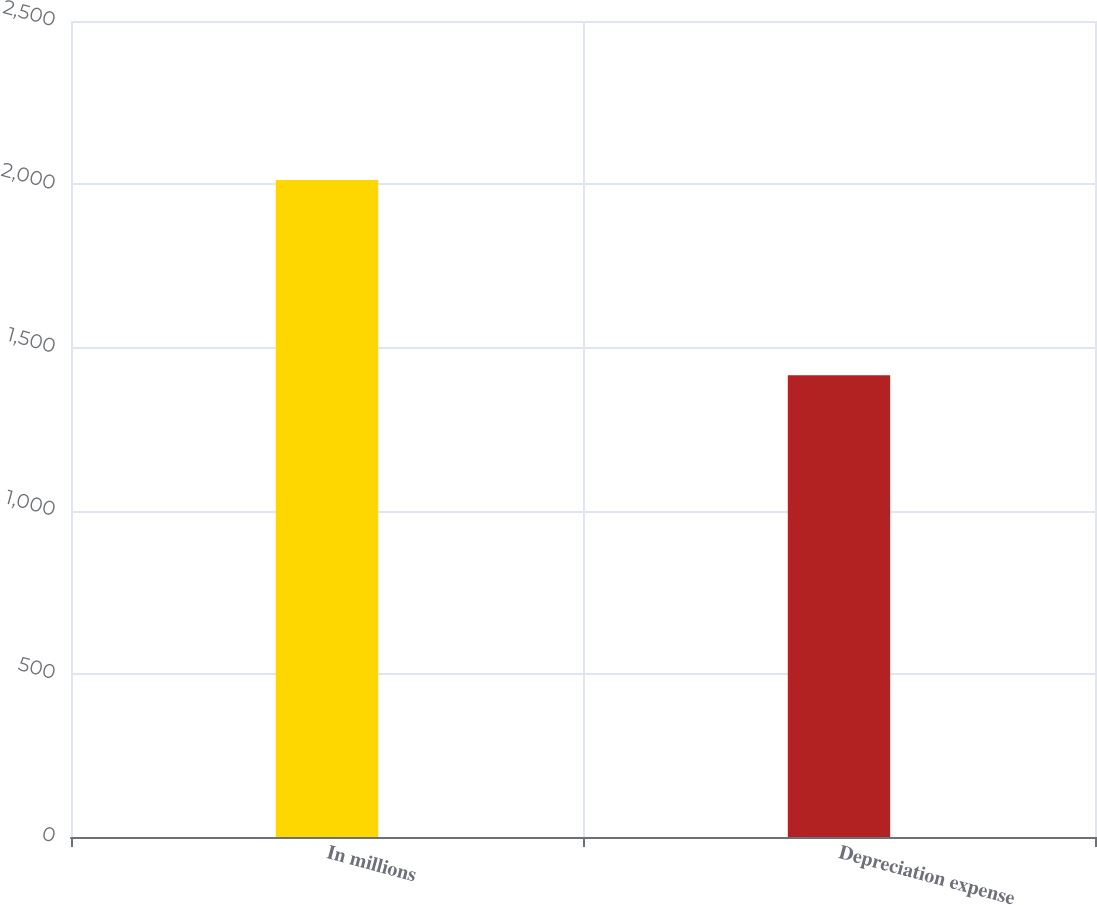Convert chart. <chart><loc_0><loc_0><loc_500><loc_500><bar_chart><fcel>In millions<fcel>Depreciation expense<nl><fcel>2013<fcel>1415<nl></chart> 